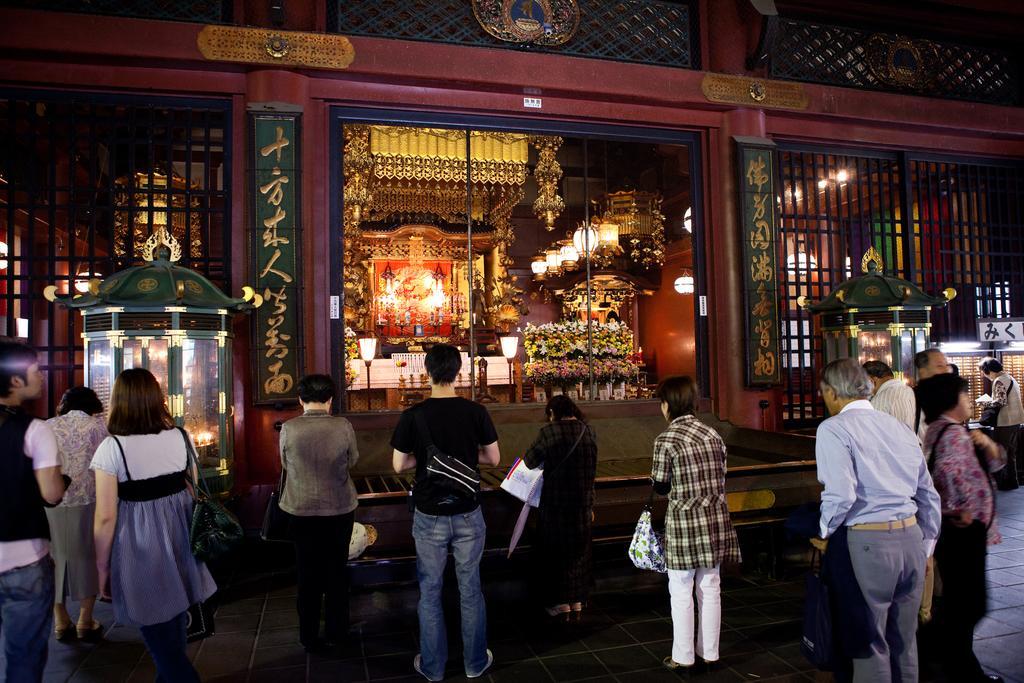In one or two sentences, can you explain what this image depicts? In this image we can see these people are standing on the road and praying. In the background, we can see lights, lamps, wooden wall and a house. 